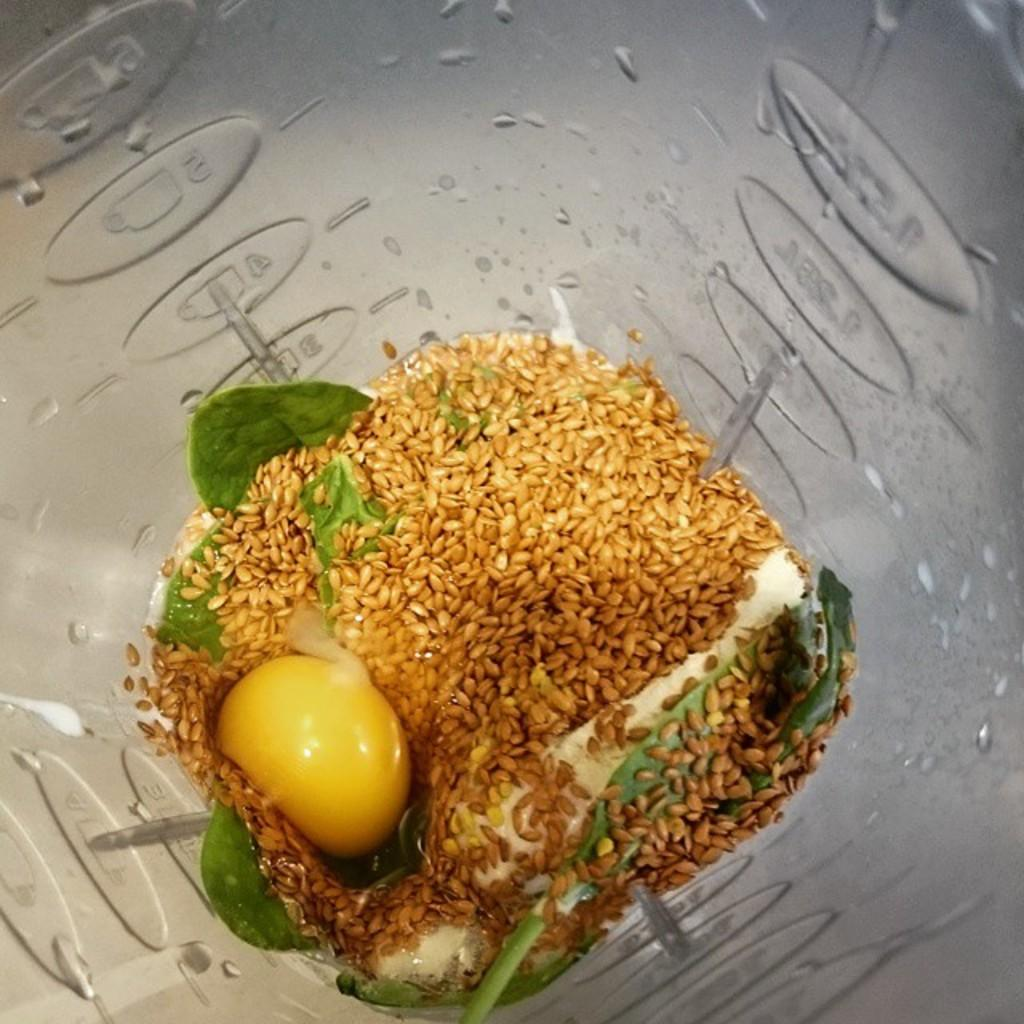What object is present in the image that contains something? There is a glass jar in the image that contains something. What is inside the glass jar? The jar contains grains and a mint leaf. Are there any other items in the jar besides grains and the mint leaf? Yes, the jar also contains vegetables. Can you describe the appearance of the jar? The jar has water droplets on it. What letter is written on the mint leaf in the image? There is no letter written on the mint leaf in the image. The mint leaf is simply a leaf, and it does not have any writing on it. 